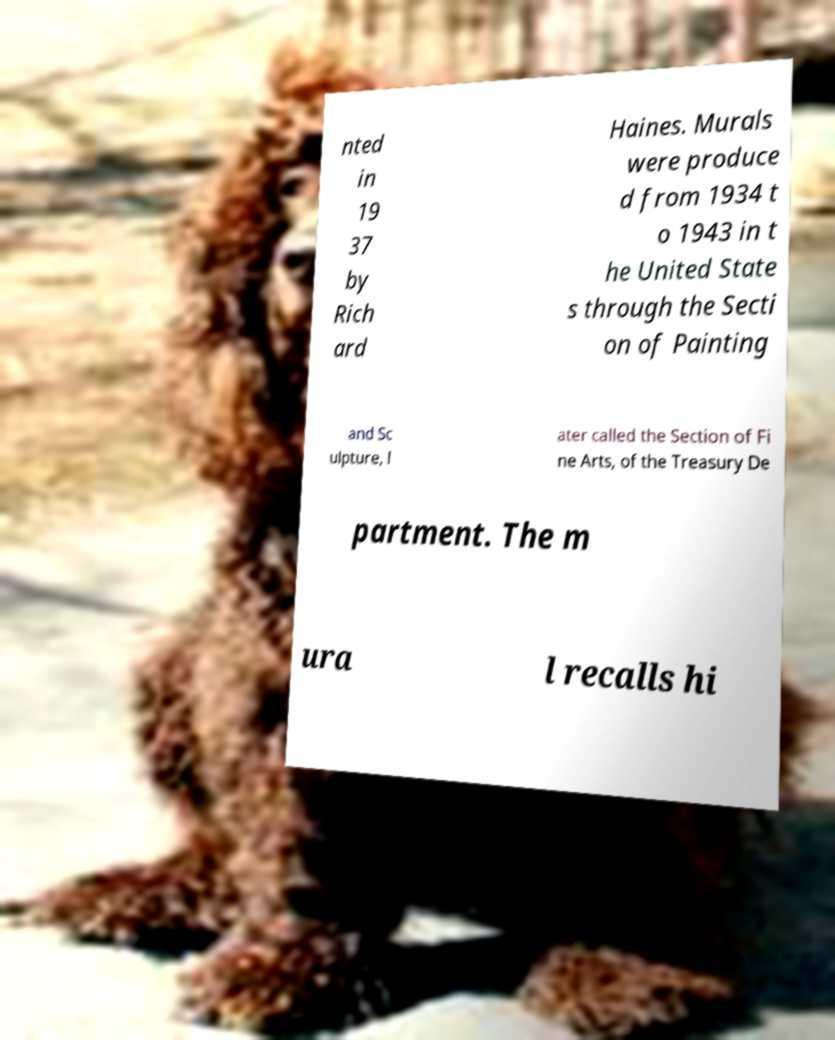I need the written content from this picture converted into text. Can you do that? nted in 19 37 by Rich ard Haines. Murals were produce d from 1934 t o 1943 in t he United State s through the Secti on of Painting and Sc ulpture, l ater called the Section of Fi ne Arts, of the Treasury De partment. The m ura l recalls hi 